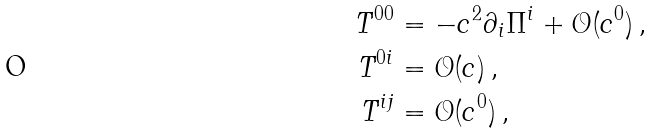<formula> <loc_0><loc_0><loc_500><loc_500>T ^ { 0 0 } & = - c ^ { 2 } \partial _ { i } \Pi ^ { i } + \mathcal { O } ( c ^ { 0 } ) \, , \\ T ^ { 0 i } & = \mathcal { O } ( c ) \, , \\ T ^ { i j } & = \mathcal { O } ( c ^ { 0 } ) \, ,</formula> 